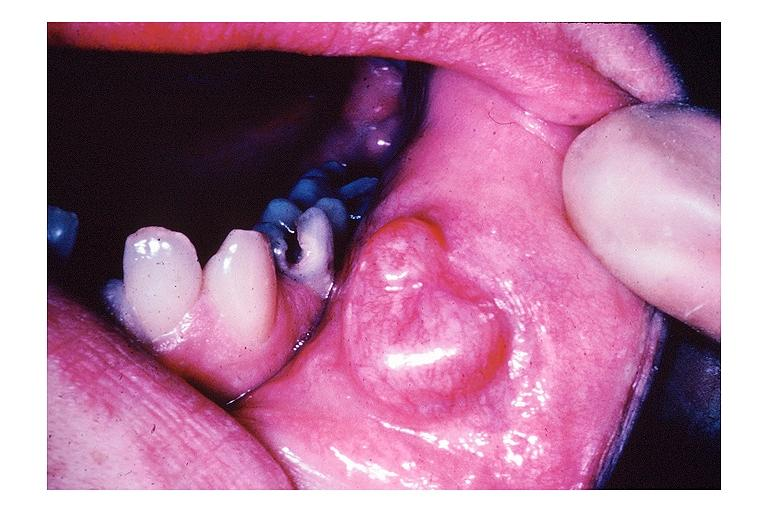what is present?
Answer the question using a single word or phrase. Oral 